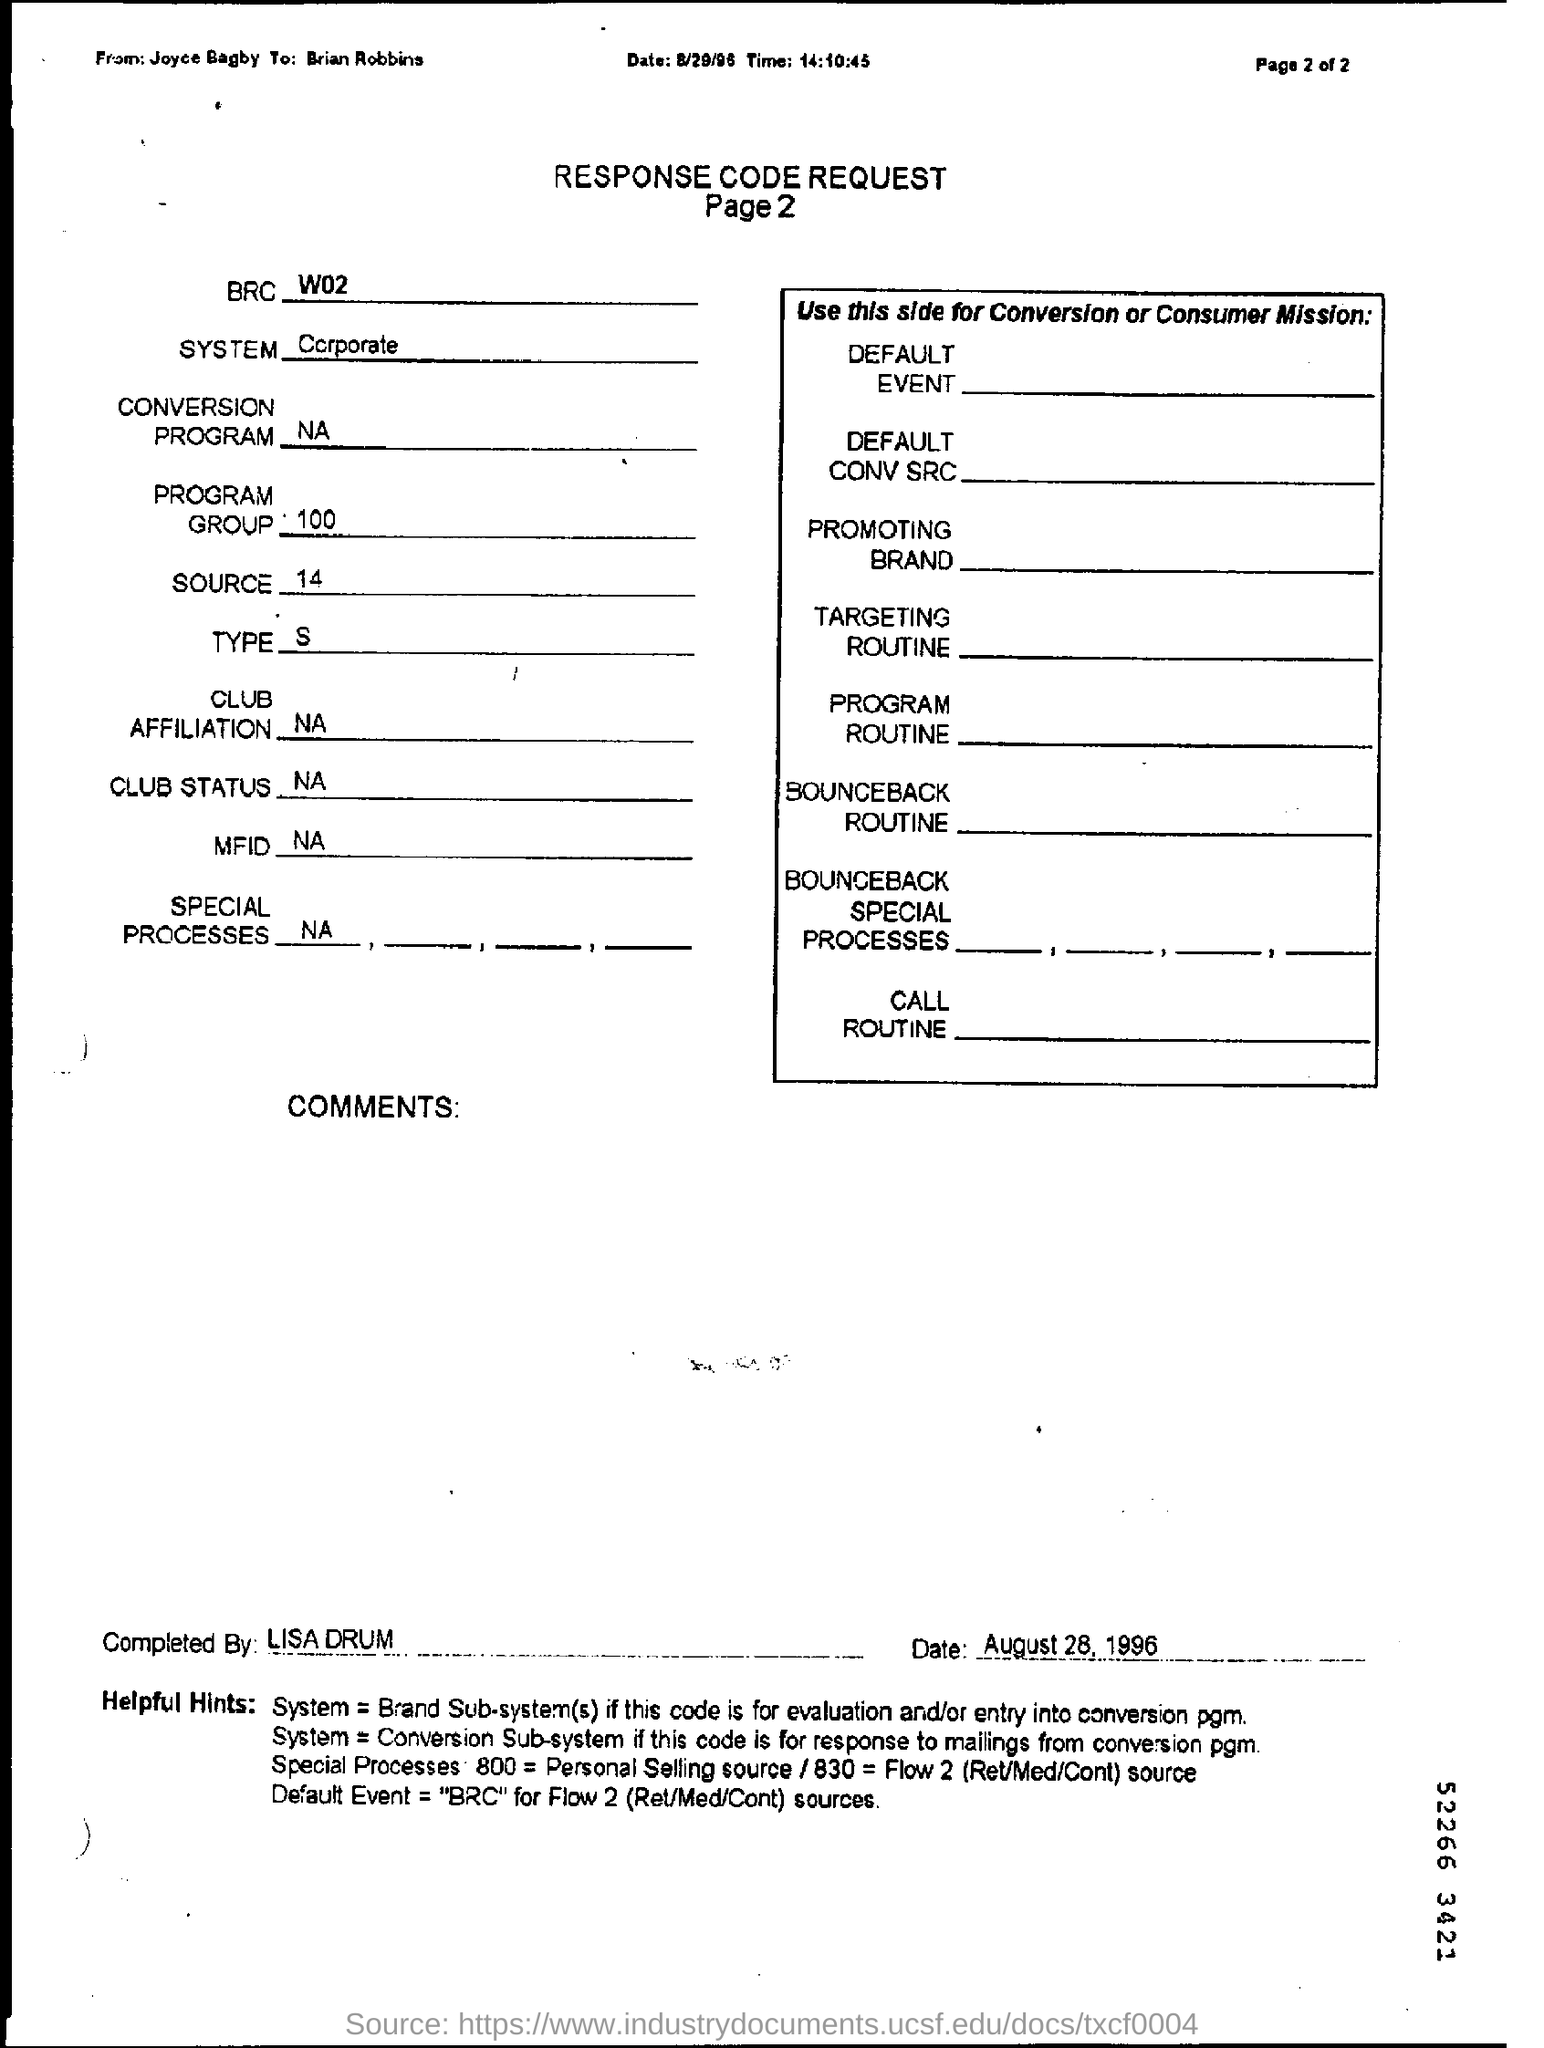Who might have used this document, based on its content and format? This document would likely be used by employees in a corporate marketing or sales department, possibly those dealing with direct mail campaigns or customer relationship management systems. Given the date, it appears to be from a time when such processes were more manual, suggesting that staff members would fill out these forms to track customer interactions and the effectiveness of various promotional strategies. 